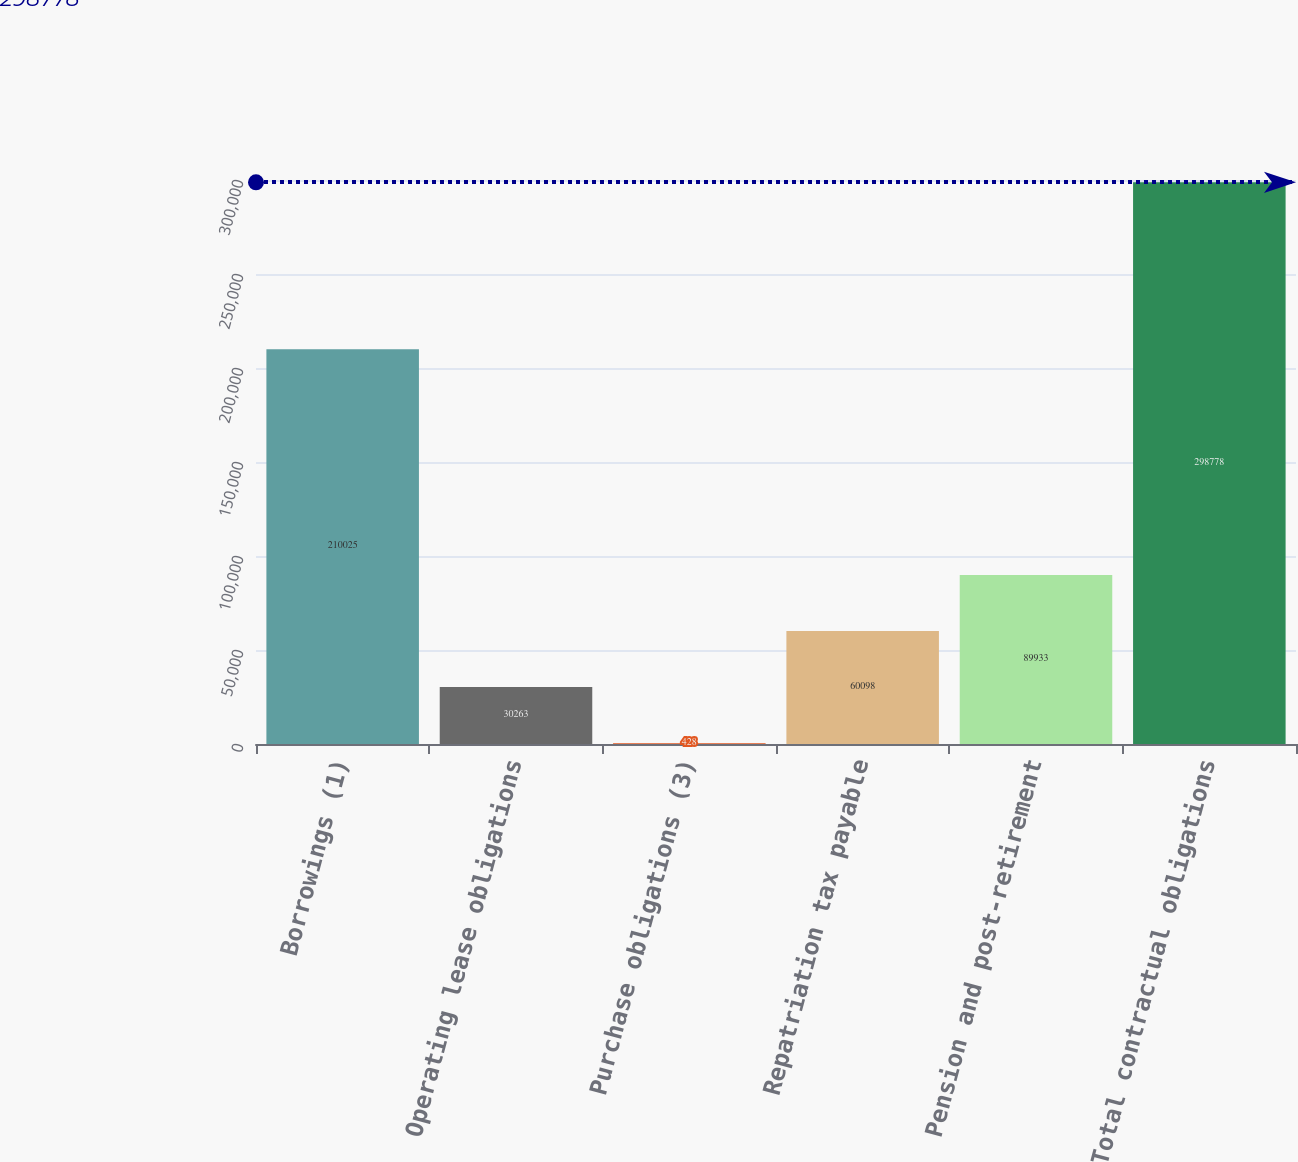Convert chart. <chart><loc_0><loc_0><loc_500><loc_500><bar_chart><fcel>Borrowings (1)<fcel>Operating lease obligations<fcel>Purchase obligations (3)<fcel>Repatriation tax payable<fcel>Pension and post-retirement<fcel>Total contractual obligations<nl><fcel>210025<fcel>30263<fcel>428<fcel>60098<fcel>89933<fcel>298778<nl></chart> 